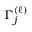Convert formula to latex. <formula><loc_0><loc_0><loc_500><loc_500>\Gamma _ { j } ^ { ( \ell ) }</formula> 